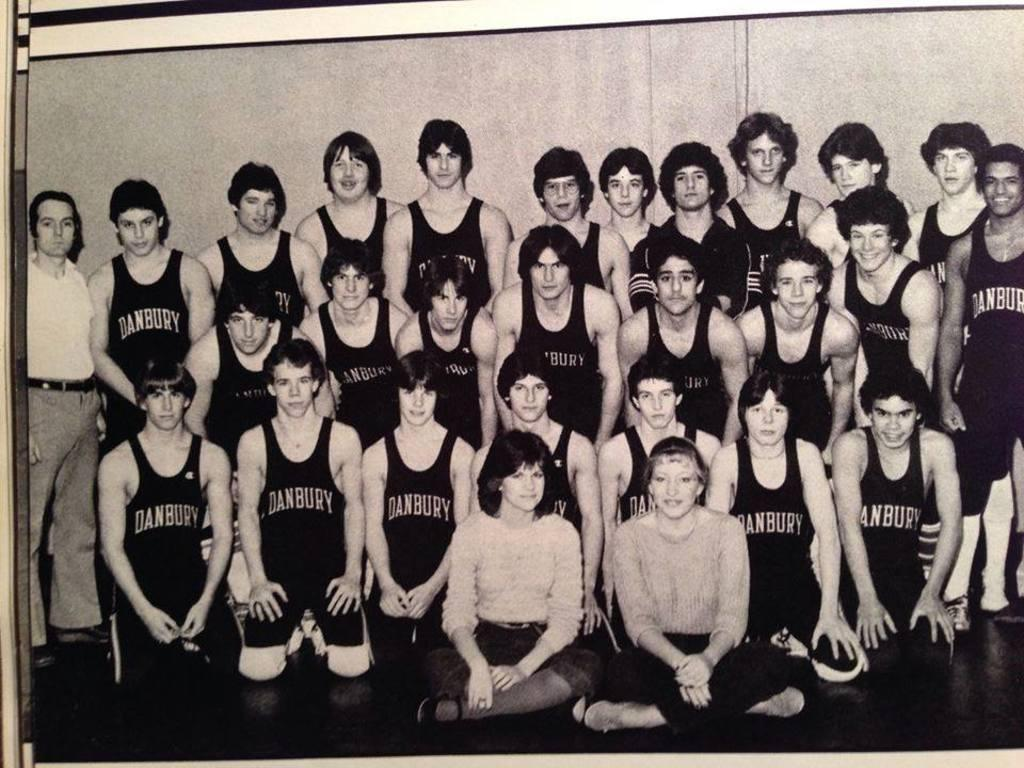<image>
Offer a succinct explanation of the picture presented. a black and white group photo of the danbury basketball team 